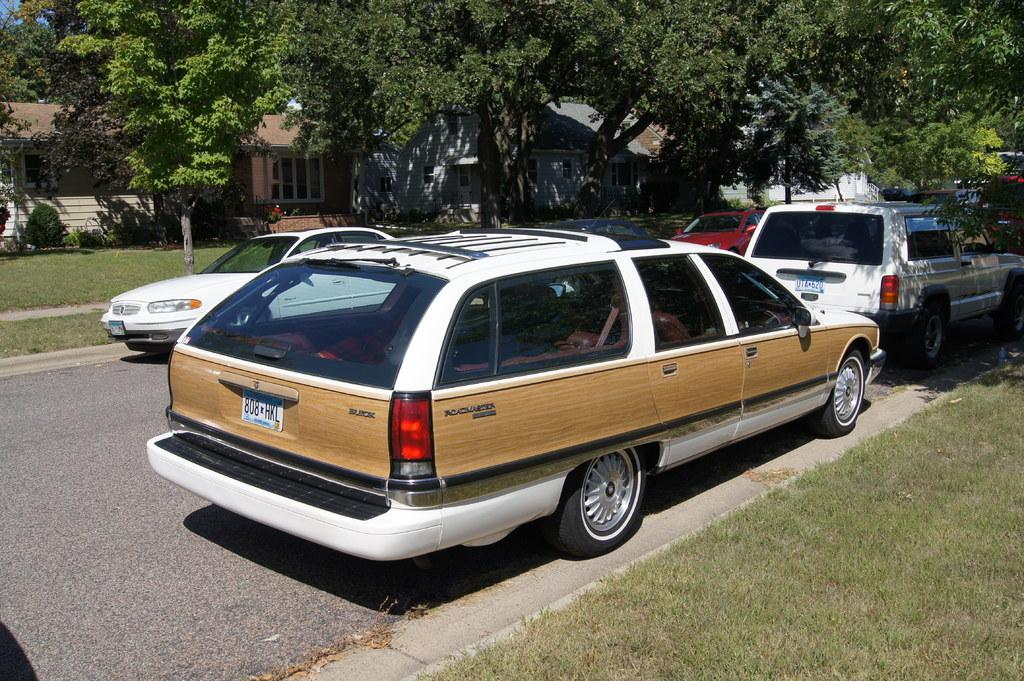<image>
Render a clear and concise summary of the photo. A station wagon with the license plate number 808 HKL is parked on the curb. 